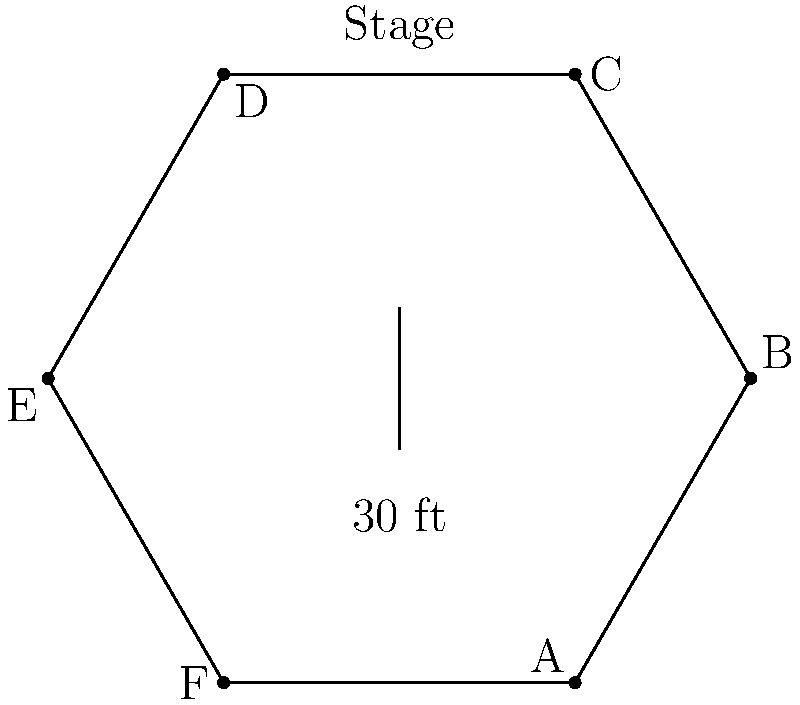As a Hollywood executive, you're considering acquiring the movie rights to a book that features a pivotal scene in a uniquely designed hexagonal theater. The theater's floor plan is shown above, with each side measuring 30 feet. If each audience member requires 6 square feet of space, what is the maximum seating capacity of this theater, assuming 20% of the floor space is reserved for aisles and walkways? Let's approach this step-by-step:

1) First, we need to calculate the area of the hexagonal theater:
   - The formula for the area of a regular hexagon is $A = \frac{3\sqrt{3}}{2}s^2$, where $s$ is the side length.
   - With $s = 30$ feet, we get:
     $A = \frac{3\sqrt{3}}{2}(30)^2 = 2338.26$ square feet

2) Now, we need to account for the 20% reserved for aisles and walkways:
   - Available space = 80% of total area
   - $2338.26 * 0.8 = 1870.61$ square feet

3) Each audience member requires 6 square feet:
   - Maximum number of seats = Available space / Space per person
   - $1870.61 / 6 = 311.77$

4) Since we can't have partial seats, we round down to the nearest whole number:
   311 seats

This calculation provides the maximum seating capacity while ensuring comfortable space for each audience member and maintaining necessary walkways.
Answer: 311 seats 